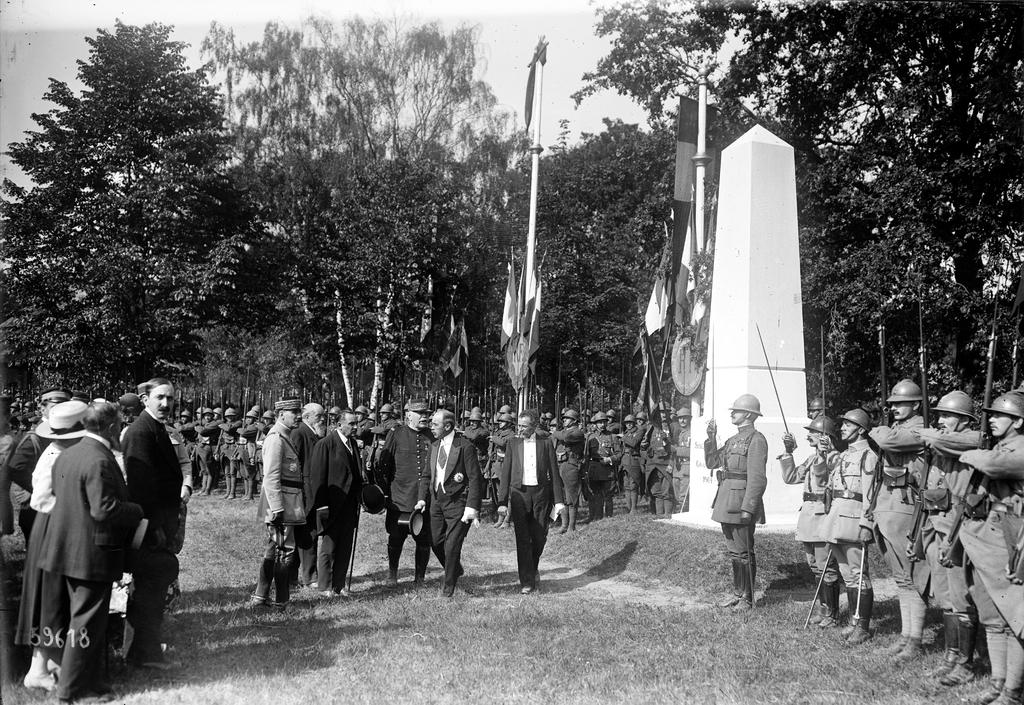What is the color scheme of the image? The image is black and white. What can be seen in the image besides the color scheme? There are people standing and trees visible in the image. What type of structure is located on the right side of the image? There is a concrete tower on the right side of the image. How many tickets are being sold in the image? There is no mention of tickets or any activity related to selling them in the image. 